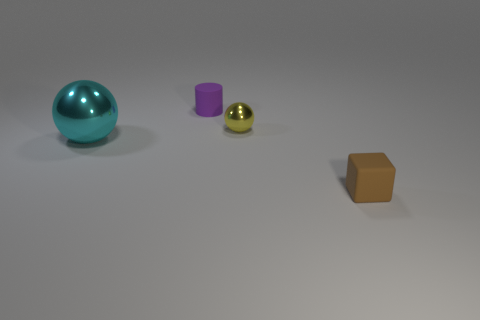There is a purple cylinder; is it the same size as the shiny sphere left of the yellow thing? The purple cylinder is smaller in height and diameter compared to the shiny teal sphere to its left, which is nearer to the yellow, reflective sphere-like object. 